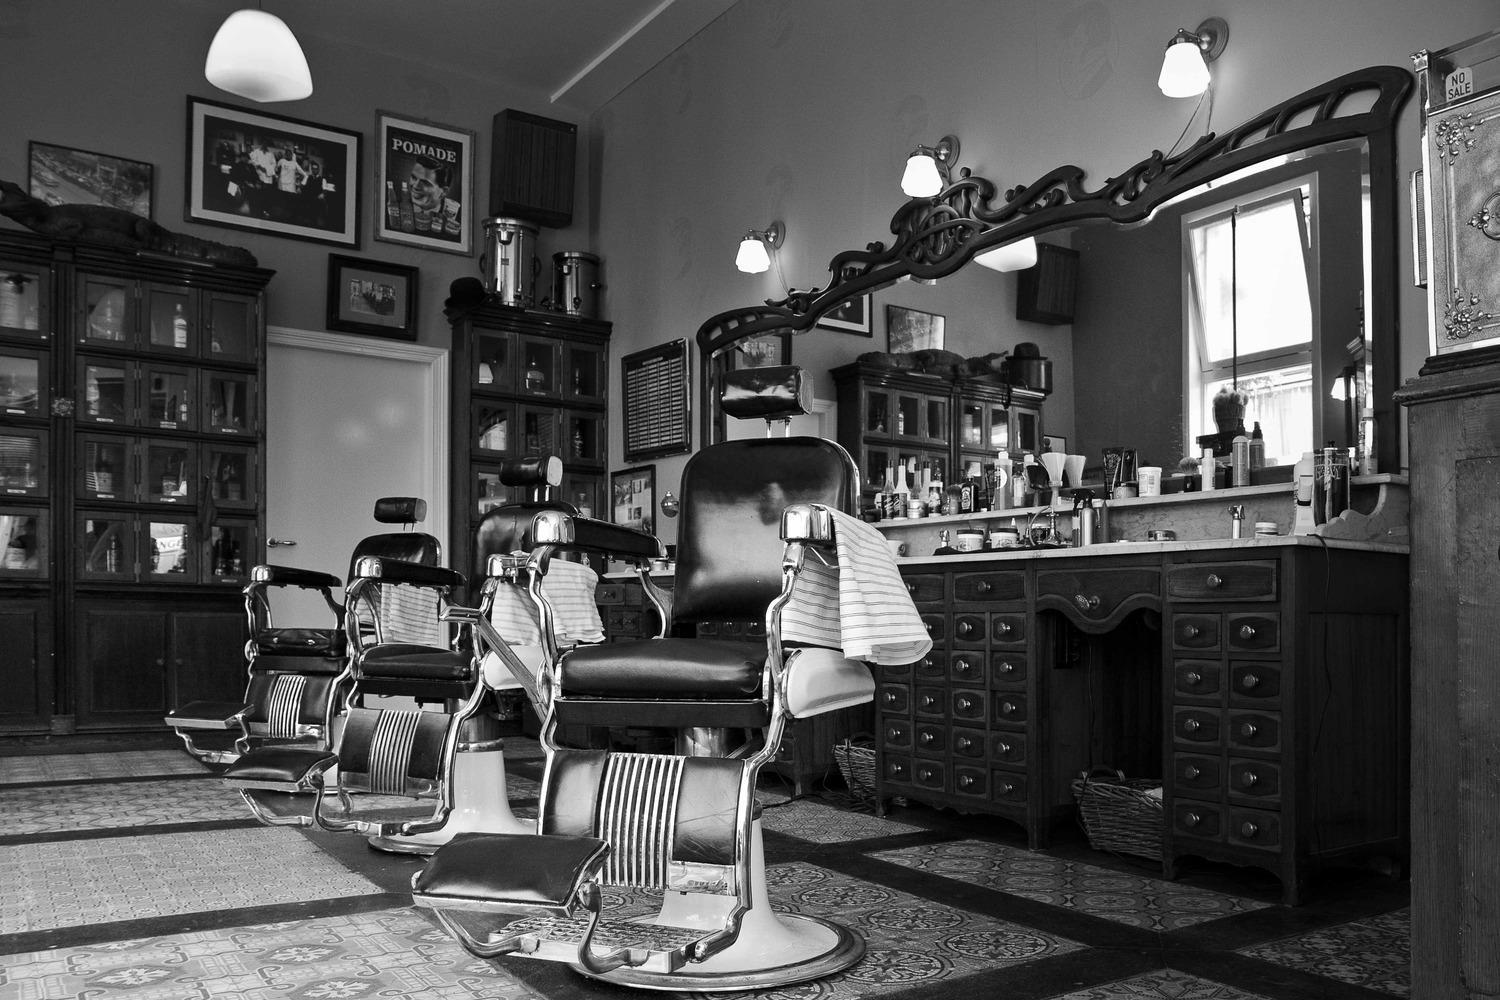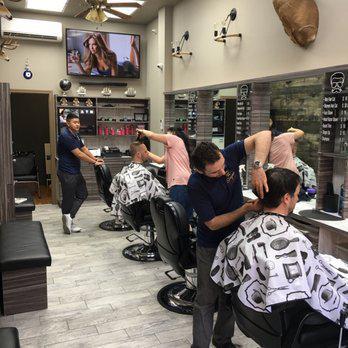The first image is the image on the left, the second image is the image on the right. Given the left and right images, does the statement "An image shows barbers working on clients' hair." hold true? Answer yes or no. Yes. The first image is the image on the left, the second image is the image on the right. Considering the images on both sides, is "Barbers are cutting their clients' hair." valid? Answer yes or no. Yes. 